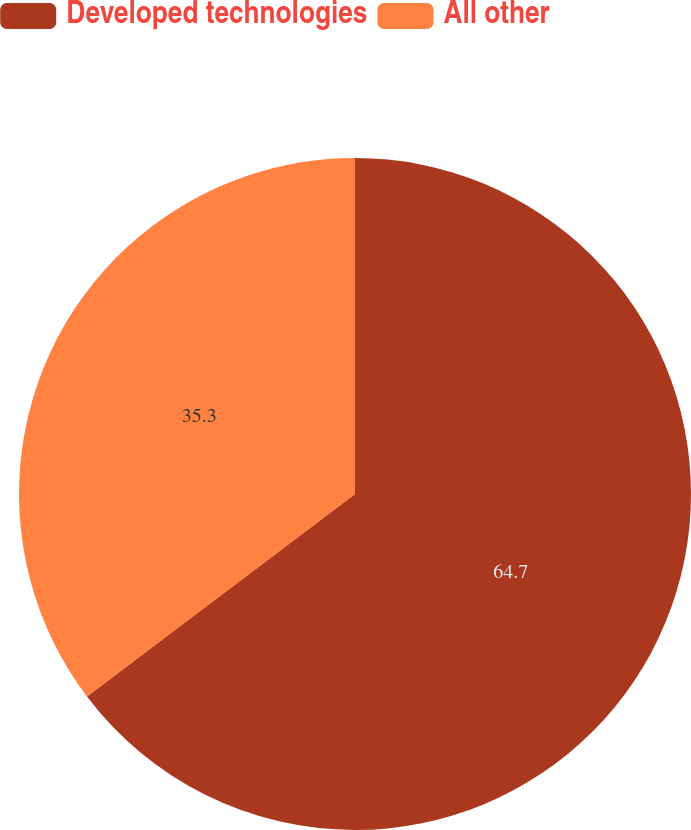Convert chart to OTSL. <chart><loc_0><loc_0><loc_500><loc_500><pie_chart><fcel>Developed technologies<fcel>All other<nl><fcel>64.7%<fcel>35.3%<nl></chart> 